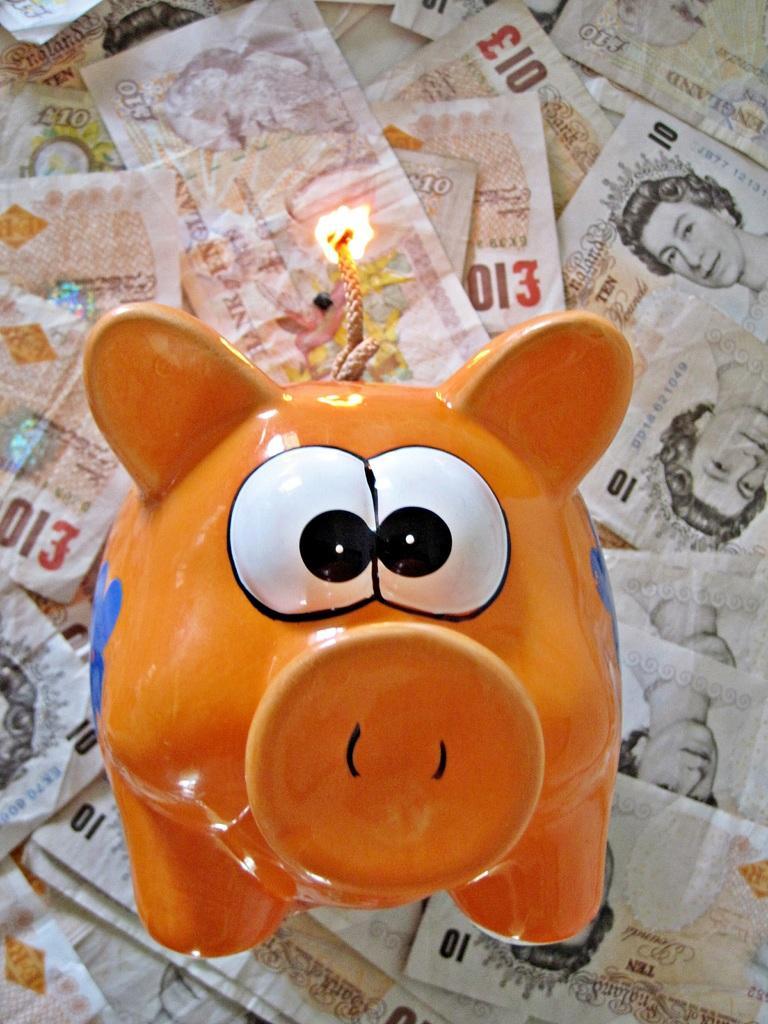How would you summarize this image in a sentence or two? There is a toy present in the middle of this image. We can see currency notes in the background. 